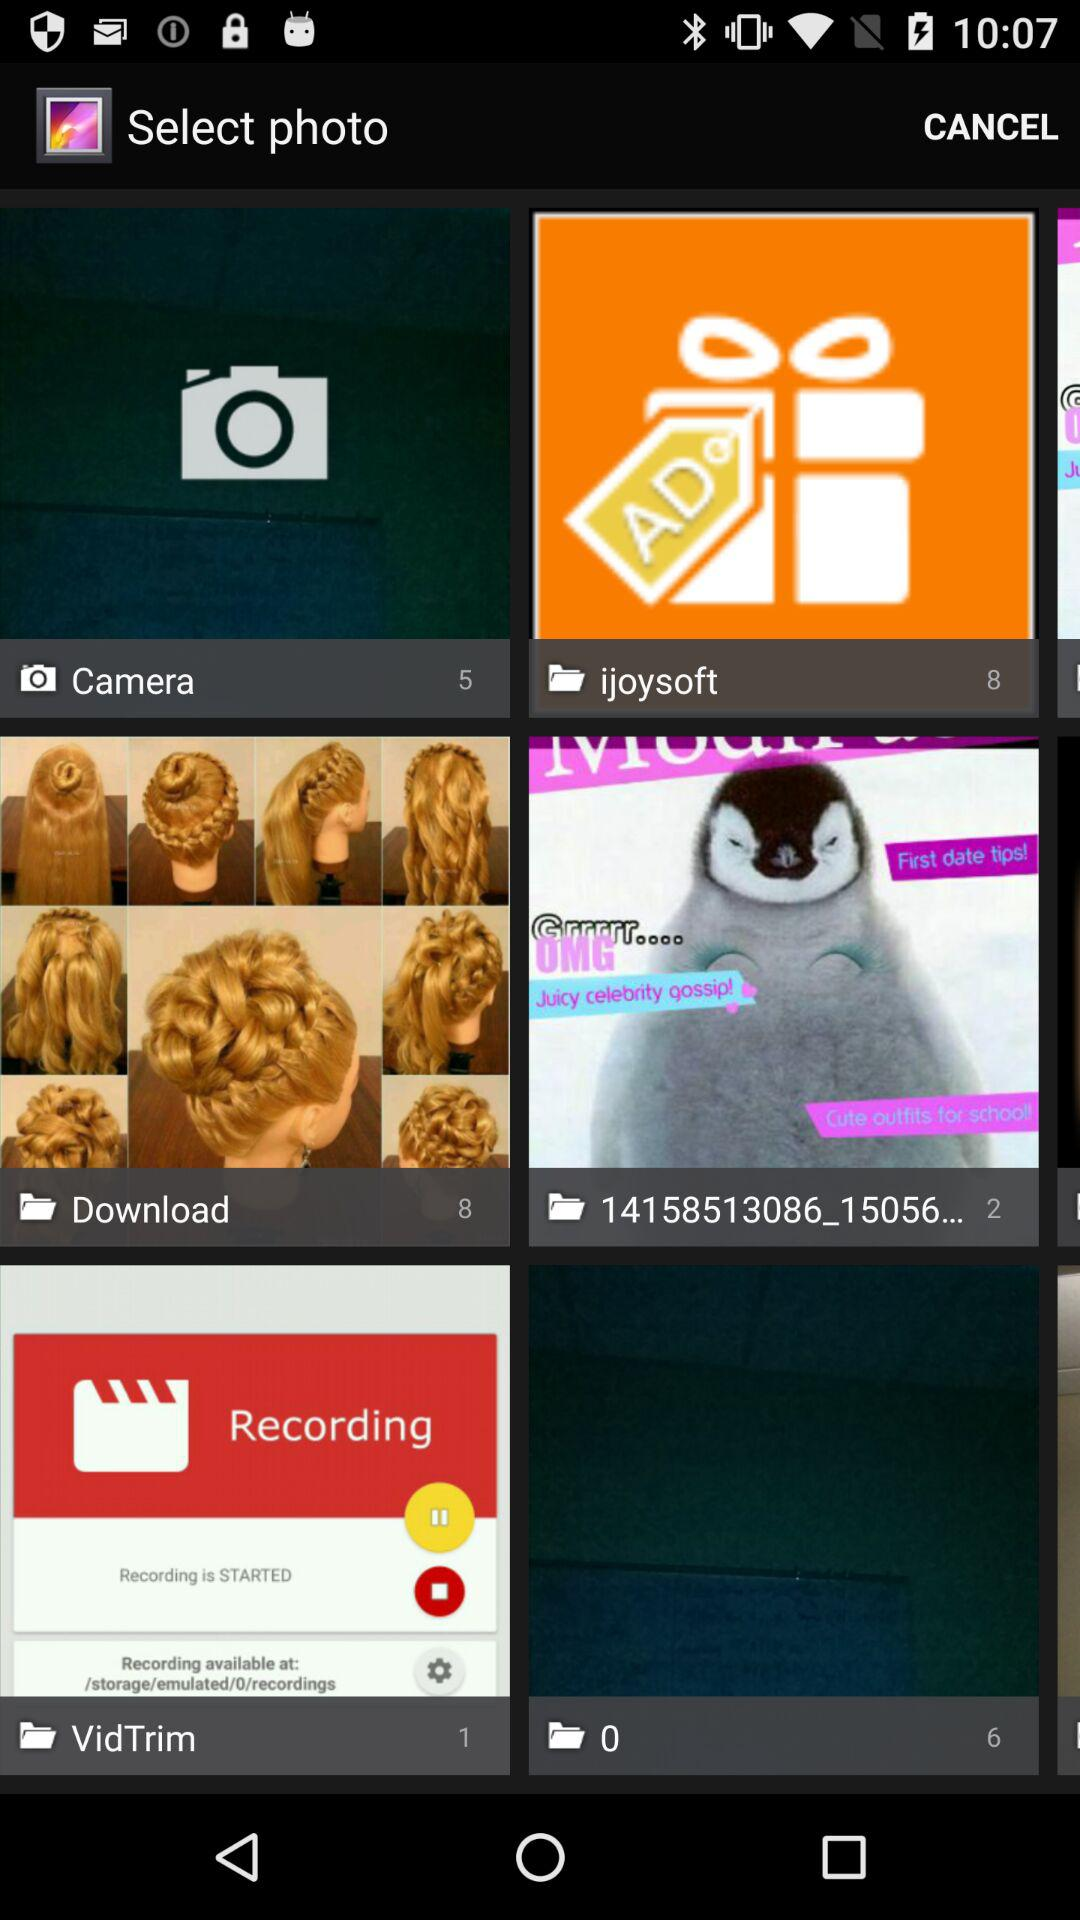What is the number of photos in the "Camera" folder? The number of photos in the "Camera" folder is 5. 